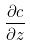<formula> <loc_0><loc_0><loc_500><loc_500>\frac { \partial c } { \partial z }</formula> 